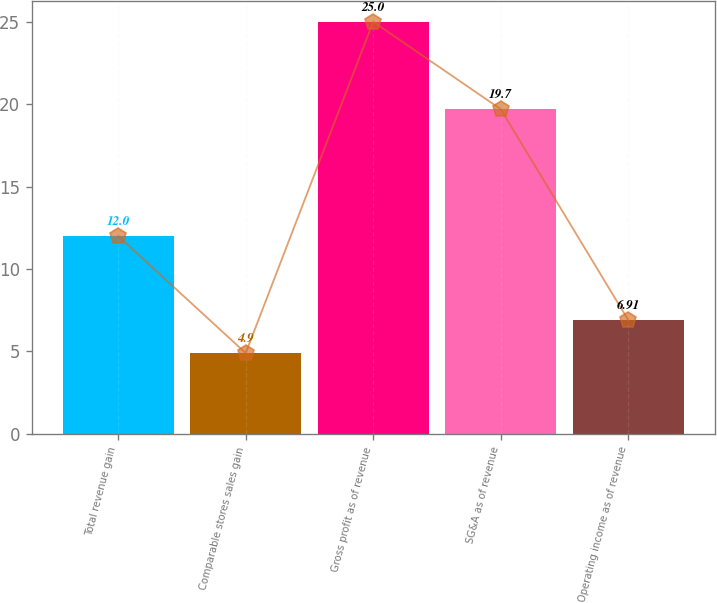<chart> <loc_0><loc_0><loc_500><loc_500><bar_chart><fcel>Total revenue gain<fcel>Comparable stores sales gain<fcel>Gross profit as of revenue<fcel>SG&A as of revenue<fcel>Operating income as of revenue<nl><fcel>12<fcel>4.9<fcel>25<fcel>19.7<fcel>6.91<nl></chart> 